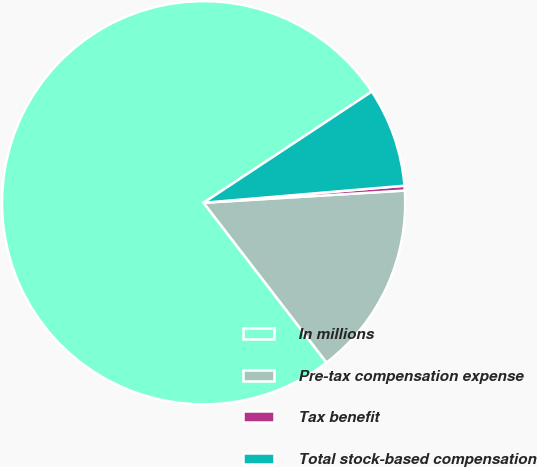Convert chart. <chart><loc_0><loc_0><loc_500><loc_500><pie_chart><fcel>In millions<fcel>Pre-tax compensation expense<fcel>Tax benefit<fcel>Total stock-based compensation<nl><fcel>76.14%<fcel>15.53%<fcel>0.38%<fcel>7.95%<nl></chart> 